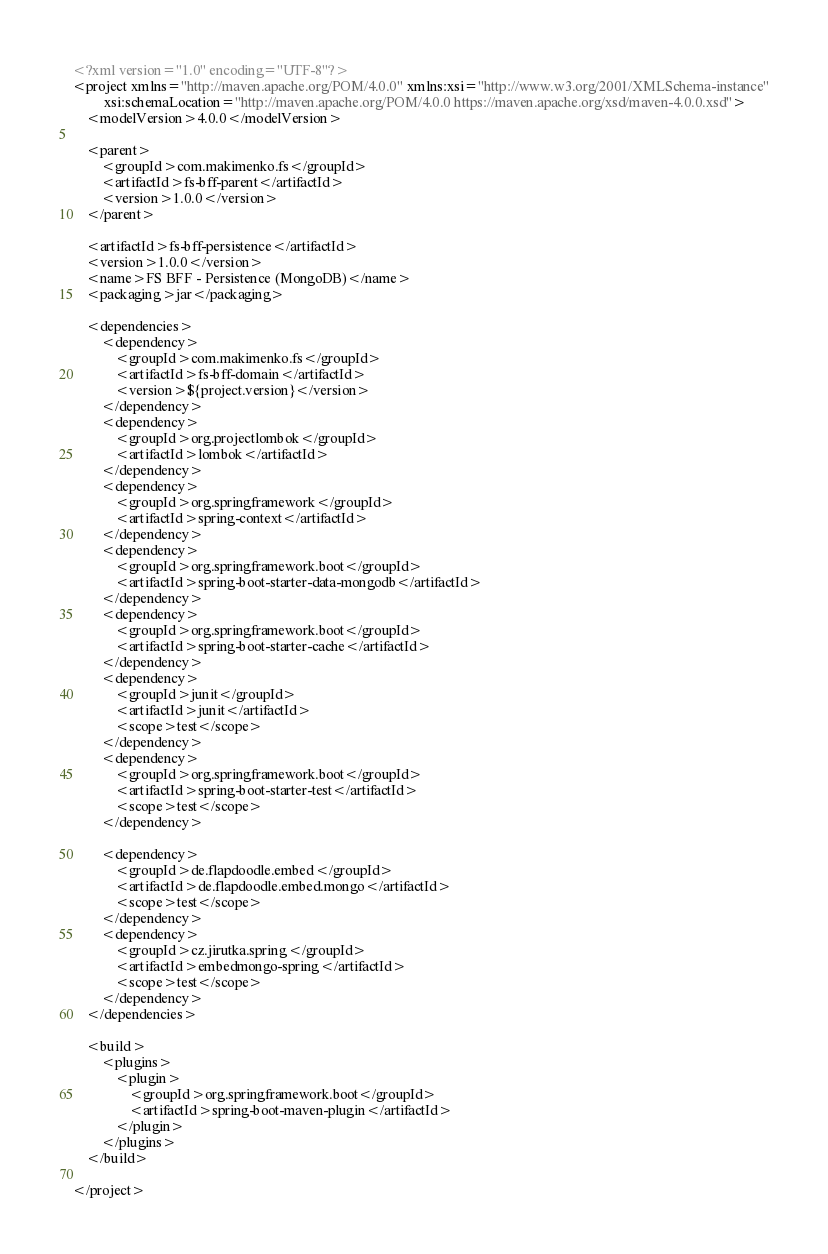<code> <loc_0><loc_0><loc_500><loc_500><_XML_><?xml version="1.0" encoding="UTF-8"?>
<project xmlns="http://maven.apache.org/POM/4.0.0" xmlns:xsi="http://www.w3.org/2001/XMLSchema-instance"
         xsi:schemaLocation="http://maven.apache.org/POM/4.0.0 https://maven.apache.org/xsd/maven-4.0.0.xsd">
    <modelVersion>4.0.0</modelVersion>

    <parent>
        <groupId>com.makimenko.fs</groupId>
        <artifactId>fs-bff-parent</artifactId>
        <version>1.0.0</version>
    </parent>

    <artifactId>fs-bff-persistence</artifactId>
    <version>1.0.0</version>
    <name>FS BFF - Persistence (MongoDB)</name>
    <packaging>jar</packaging>

    <dependencies>
        <dependency>
            <groupId>com.makimenko.fs</groupId>
            <artifactId>fs-bff-domain</artifactId>
            <version>${project.version}</version>
        </dependency>
        <dependency>
            <groupId>org.projectlombok</groupId>
            <artifactId>lombok</artifactId>
        </dependency>
        <dependency>
            <groupId>org.springframework</groupId>
            <artifactId>spring-context</artifactId>
        </dependency>
        <dependency>
            <groupId>org.springframework.boot</groupId>
            <artifactId>spring-boot-starter-data-mongodb</artifactId>
        </dependency>
        <dependency>
            <groupId>org.springframework.boot</groupId>
            <artifactId>spring-boot-starter-cache</artifactId>
        </dependency>
        <dependency>
            <groupId>junit</groupId>
            <artifactId>junit</artifactId>
            <scope>test</scope>
        </dependency>
        <dependency>
            <groupId>org.springframework.boot</groupId>
            <artifactId>spring-boot-starter-test</artifactId>
            <scope>test</scope>
        </dependency>

        <dependency>
            <groupId>de.flapdoodle.embed</groupId>
            <artifactId>de.flapdoodle.embed.mongo</artifactId>
            <scope>test</scope>
        </dependency>
        <dependency>
            <groupId>cz.jirutka.spring</groupId>
            <artifactId>embedmongo-spring</artifactId>
            <scope>test</scope>
        </dependency>
    </dependencies>

    <build>
        <plugins>
            <plugin>
                <groupId>org.springframework.boot</groupId>
                <artifactId>spring-boot-maven-plugin</artifactId>
            </plugin>
        </plugins>
    </build>

</project>
</code> 